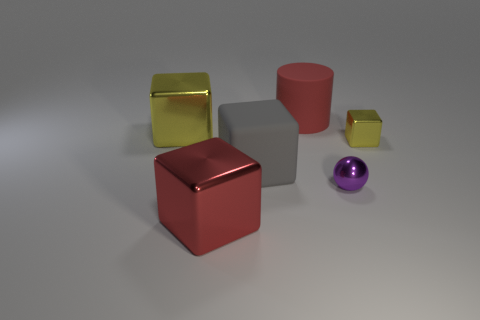Subtract all big red metallic cubes. How many cubes are left? 3 Add 1 red matte objects. How many objects exist? 7 Subtract all red cylinders. How many yellow blocks are left? 2 Subtract all yellow cubes. How many cubes are left? 2 Subtract all tiny red metallic cylinders. Subtract all tiny purple objects. How many objects are left? 5 Add 4 big rubber cylinders. How many big rubber cylinders are left? 5 Add 3 small metallic balls. How many small metallic balls exist? 4 Subtract 0 blue cylinders. How many objects are left? 6 Subtract all cylinders. How many objects are left? 5 Subtract 4 blocks. How many blocks are left? 0 